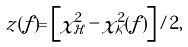<formula> <loc_0><loc_0><loc_500><loc_500>z ( f ) = \left [ \chi _ { \mathcal { H } } ^ { 2 } - \chi _ { \mathcal { K } } ^ { 2 } ( f ) \right ] / 2 ,</formula> 